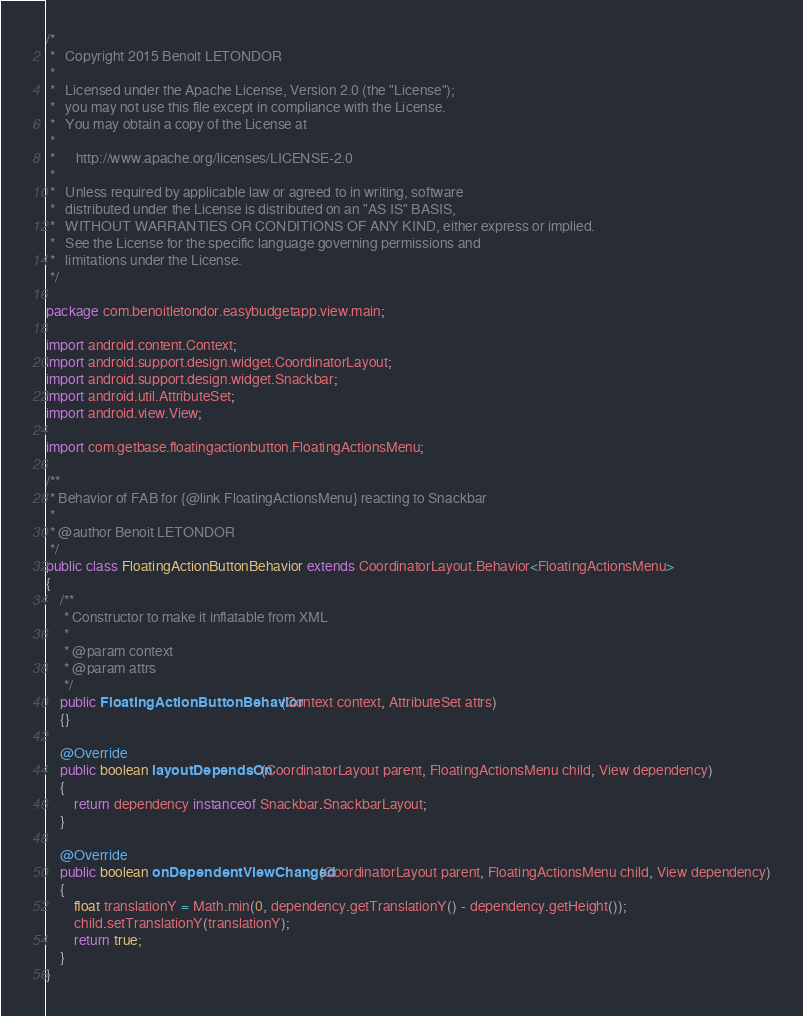<code> <loc_0><loc_0><loc_500><loc_500><_Java_>/*
 *   Copyright 2015 Benoit LETONDOR
 *
 *   Licensed under the Apache License, Version 2.0 (the "License");
 *   you may not use this file except in compliance with the License.
 *   You may obtain a copy of the License at
 *
 *      http://www.apache.org/licenses/LICENSE-2.0
 *
 *   Unless required by applicable law or agreed to in writing, software
 *   distributed under the License is distributed on an "AS IS" BASIS,
 *   WITHOUT WARRANTIES OR CONDITIONS OF ANY KIND, either express or implied.
 *   See the License for the specific language governing permissions and
 *   limitations under the License.
 */

package com.benoitletondor.easybudgetapp.view.main;

import android.content.Context;
import android.support.design.widget.CoordinatorLayout;
import android.support.design.widget.Snackbar;
import android.util.AttributeSet;
import android.view.View;

import com.getbase.floatingactionbutton.FloatingActionsMenu;

/**
 * Behavior of FAB for {@link FloatingActionsMenu} reacting to Snackbar
 *
 * @author Benoit LETONDOR
 */
public class FloatingActionButtonBehavior extends CoordinatorLayout.Behavior<FloatingActionsMenu>
{
    /**
     * Constructor to make it inflatable from XML
     *
     * @param context
     * @param attrs
     */
    public FloatingActionButtonBehavior(Context context, AttributeSet attrs)
    {}

    @Override
    public boolean layoutDependsOn(CoordinatorLayout parent, FloatingActionsMenu child, View dependency)
    {
        return dependency instanceof Snackbar.SnackbarLayout;
    }

    @Override
    public boolean onDependentViewChanged(CoordinatorLayout parent, FloatingActionsMenu child, View dependency)
    {
        float translationY = Math.min(0, dependency.getTranslationY() - dependency.getHeight());
        child.setTranslationY(translationY);
        return true;
    }
}
</code> 